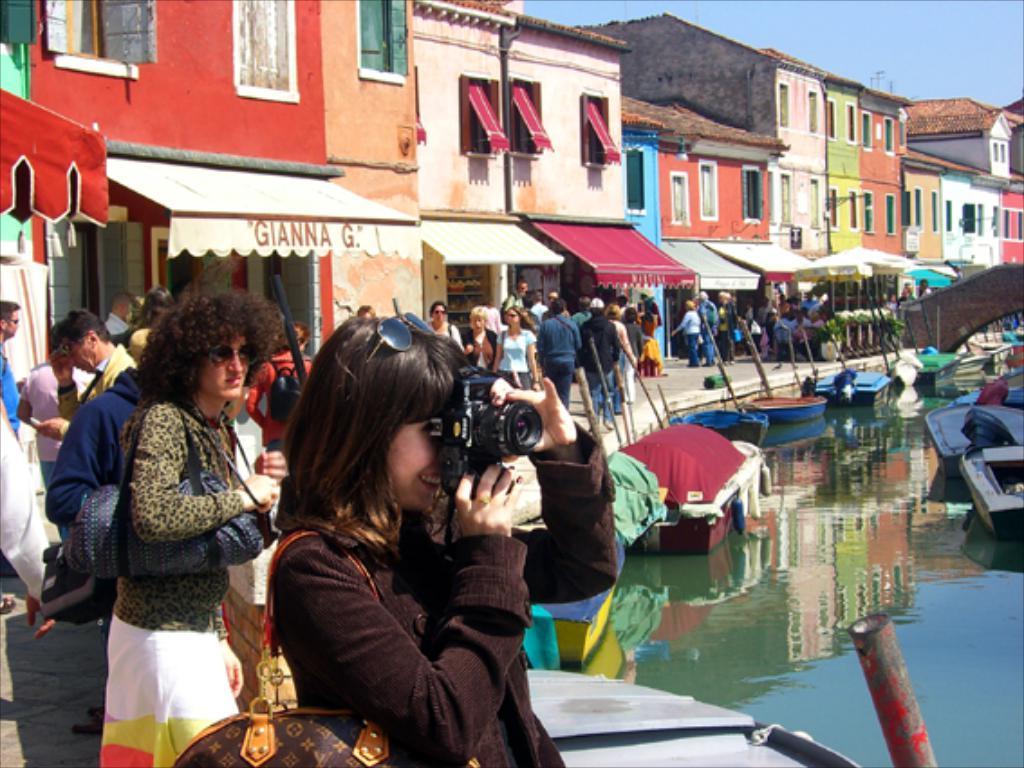Describe this image in one or two sentences. In the bottom right corner of the image there is water, above the water there are some boats. In the middle of the image few people are standing and walking and holding some bags and cameras. Behind them there are some buildings and there is a bridge. At the top of the image there is sky. 